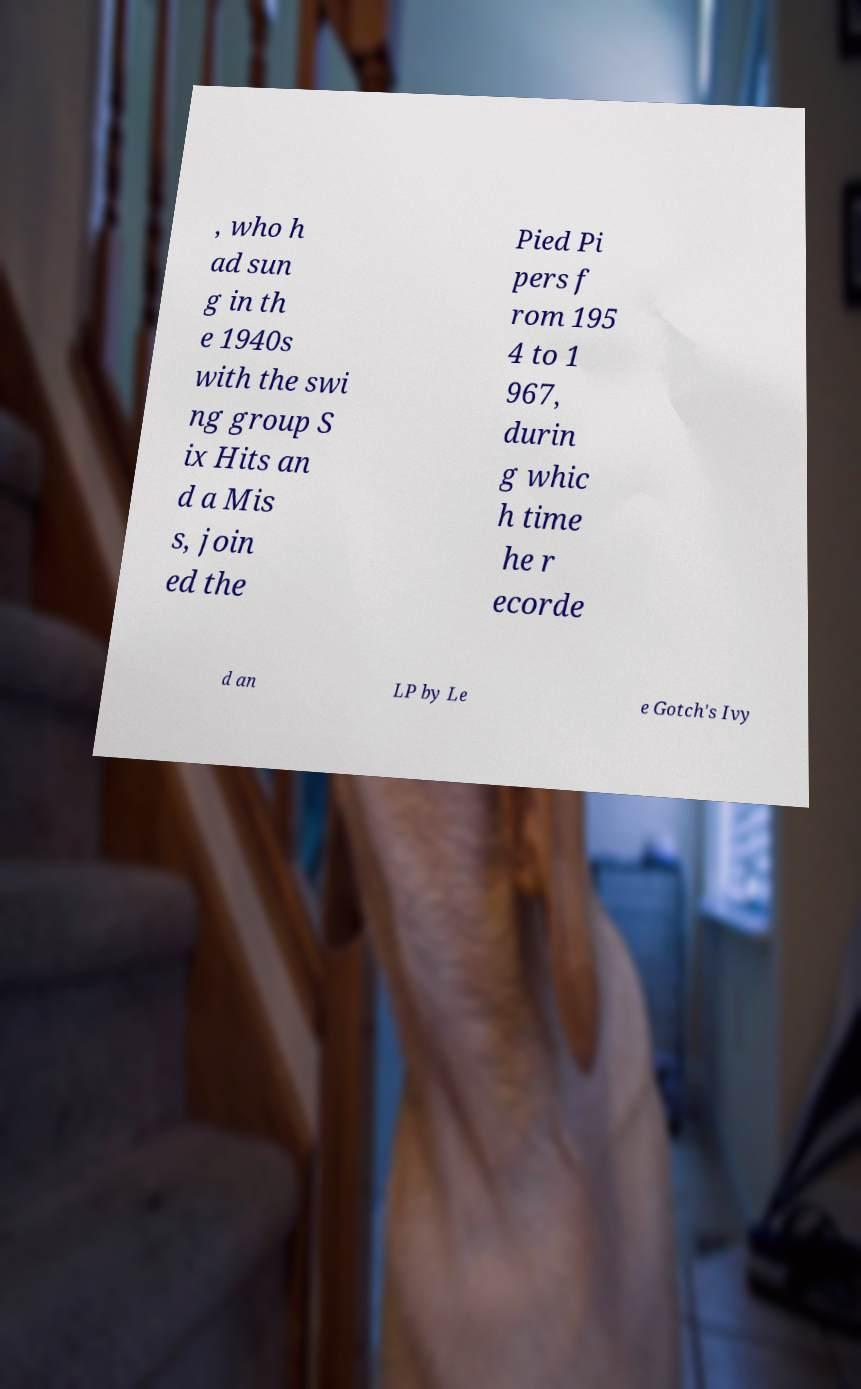Please read and relay the text visible in this image. What does it say? , who h ad sun g in th e 1940s with the swi ng group S ix Hits an d a Mis s, join ed the Pied Pi pers f rom 195 4 to 1 967, durin g whic h time he r ecorde d an LP by Le e Gotch's Ivy 